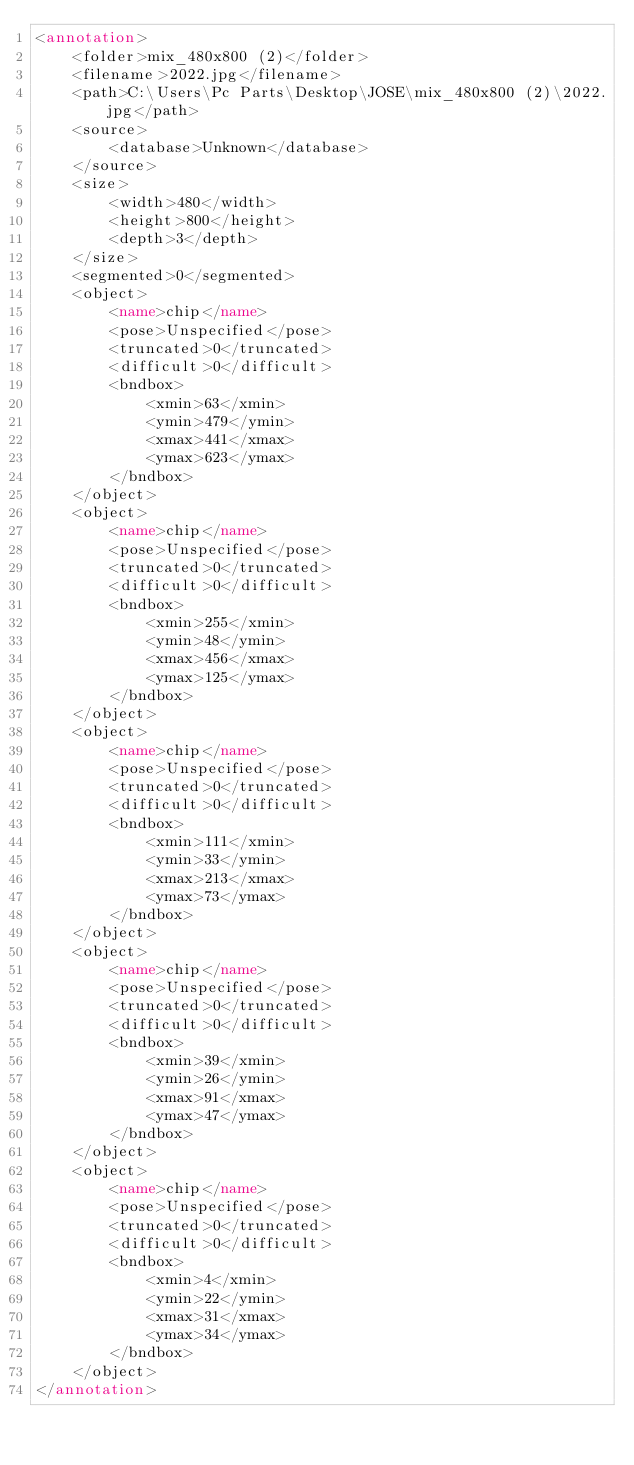<code> <loc_0><loc_0><loc_500><loc_500><_XML_><annotation>
	<folder>mix_480x800 (2)</folder>
	<filename>2022.jpg</filename>
	<path>C:\Users\Pc Parts\Desktop\JOSE\mix_480x800 (2)\2022.jpg</path>
	<source>
		<database>Unknown</database>
	</source>
	<size>
		<width>480</width>
		<height>800</height>
		<depth>3</depth>
	</size>
	<segmented>0</segmented>
	<object>
		<name>chip</name>
		<pose>Unspecified</pose>
		<truncated>0</truncated>
		<difficult>0</difficult>
		<bndbox>
			<xmin>63</xmin>
			<ymin>479</ymin>
			<xmax>441</xmax>
			<ymax>623</ymax>
		</bndbox>
	</object>
	<object>
		<name>chip</name>
		<pose>Unspecified</pose>
		<truncated>0</truncated>
		<difficult>0</difficult>
		<bndbox>
			<xmin>255</xmin>
			<ymin>48</ymin>
			<xmax>456</xmax>
			<ymax>125</ymax>
		</bndbox>
	</object>
	<object>
		<name>chip</name>
		<pose>Unspecified</pose>
		<truncated>0</truncated>
		<difficult>0</difficult>
		<bndbox>
			<xmin>111</xmin>
			<ymin>33</ymin>
			<xmax>213</xmax>
			<ymax>73</ymax>
		</bndbox>
	</object>
	<object>
		<name>chip</name>
		<pose>Unspecified</pose>
		<truncated>0</truncated>
		<difficult>0</difficult>
		<bndbox>
			<xmin>39</xmin>
			<ymin>26</ymin>
			<xmax>91</xmax>
			<ymax>47</ymax>
		</bndbox>
	</object>
	<object>
		<name>chip</name>
		<pose>Unspecified</pose>
		<truncated>0</truncated>
		<difficult>0</difficult>
		<bndbox>
			<xmin>4</xmin>
			<ymin>22</ymin>
			<xmax>31</xmax>
			<ymax>34</ymax>
		</bndbox>
	</object>
</annotation>
</code> 